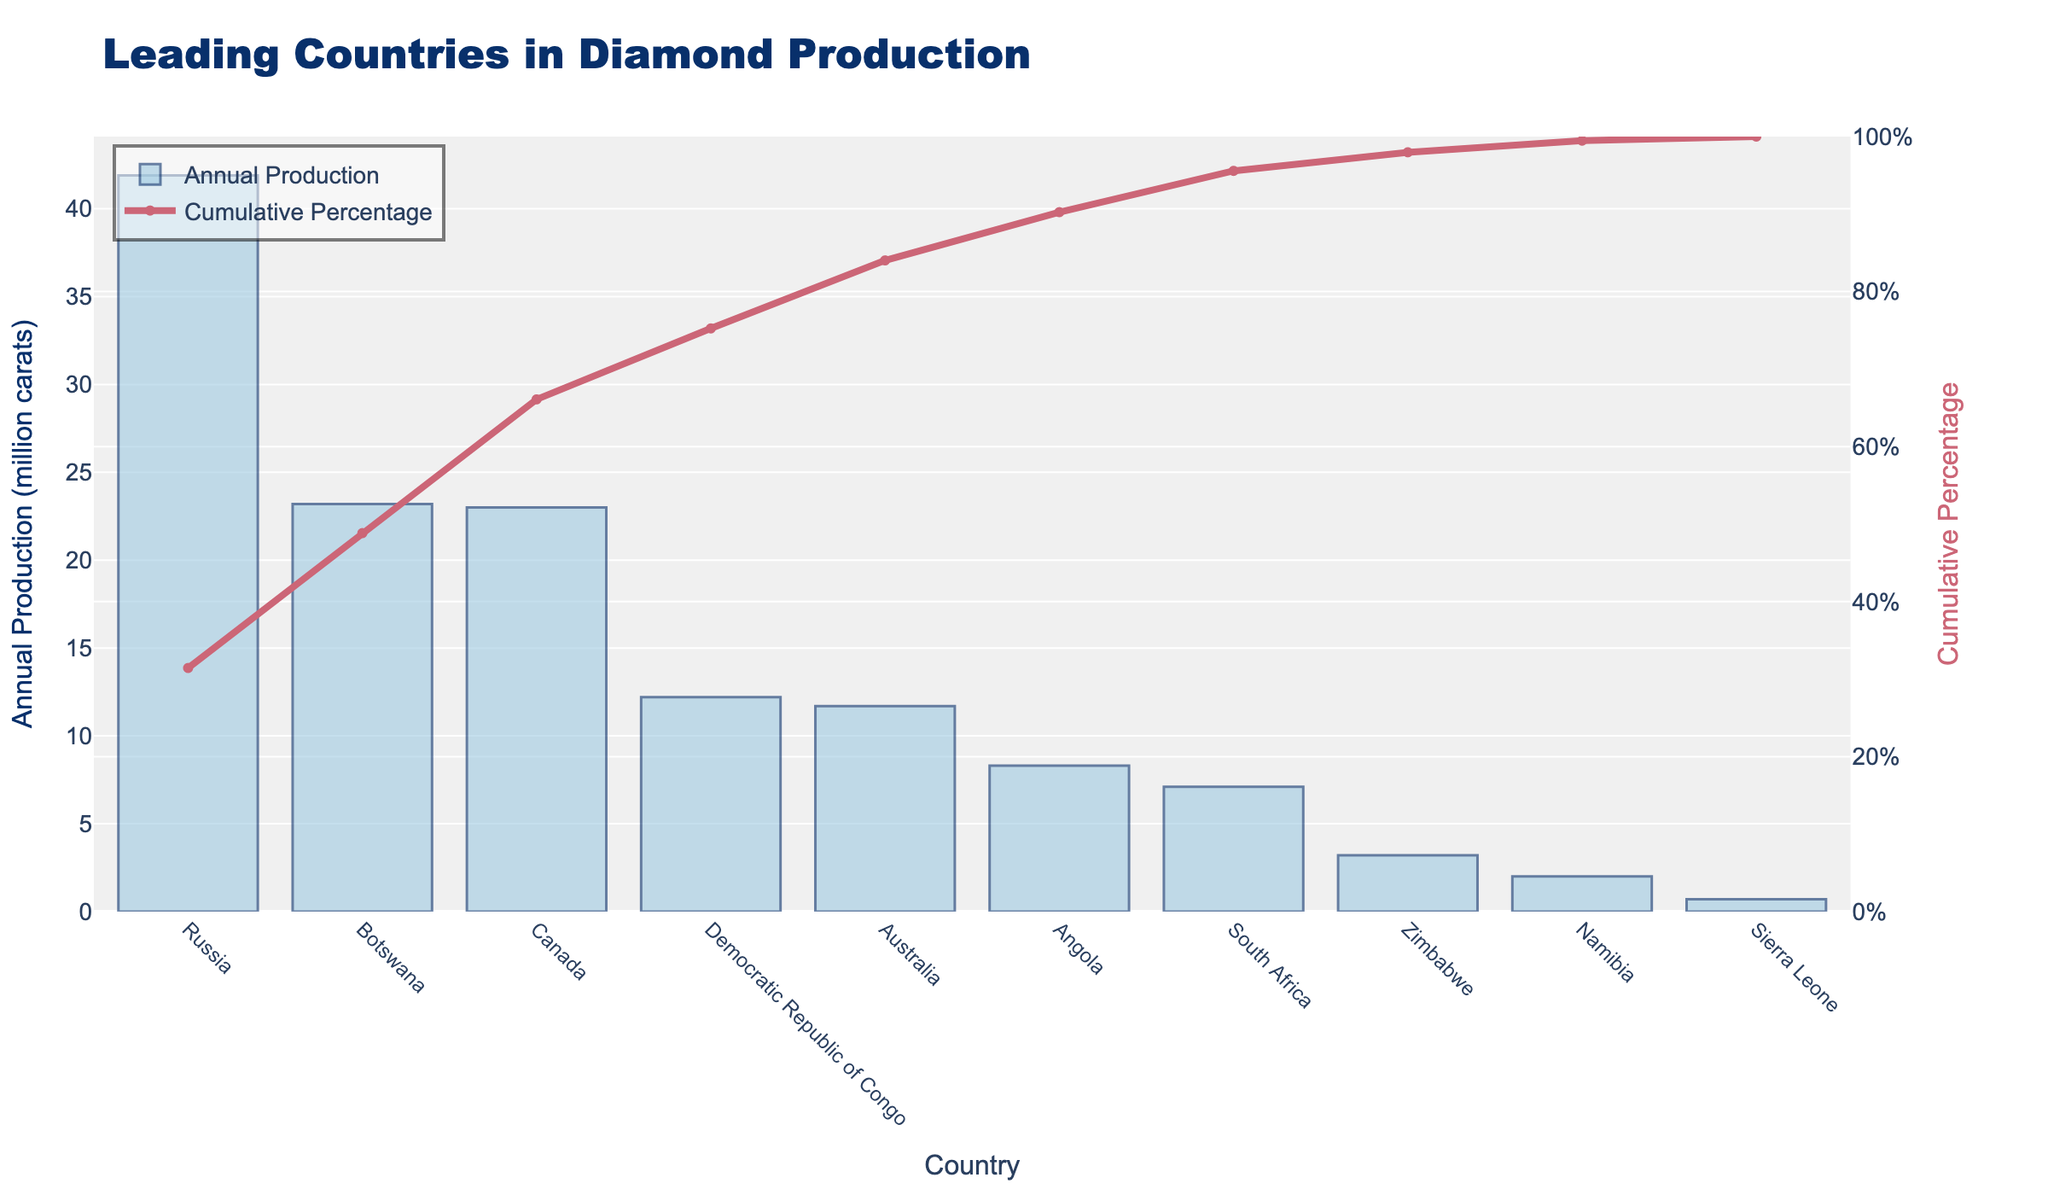What is the title of the figure? The title of the figure is displayed at the top, which is "Leading Countries in Diamond Production". This title helps identify the main subject of the figure.
Answer: Leading Countries in Diamond Production Which country has the highest annual diamond production? By observing the height of the bars, Russia has the highest bar indicating the highest annual diamond production among the countries listed.
Answer: Russia How many countries are represented in the chart? You can count the number of bars or labels on the x-axis. There are 10 countries represented in the chart.
Answer: 10 What color is used for the bars representing annual production? The color of the bars showing annual production is light blue (close to a shade of blue). This color distinction helps to identify the bars at a glance.
Answer: Light blue At what cumulative percentage is the fourth country? By looking at the cumulative percentage line, the fourth country from the left is the Democratic Republic of Congo, and its corresponding cumulative percentage on the secondary y-axis can be observed and is approximately 78%.
Answer: 78% What is the combined annual diamond production of Canada and Botswana? The annual production for Botswana is 23.2 million carats and for Canada is 23.0 million carats. Adding these gives 23.2 + 23.0 = 46.2 million carats.
Answer: 46.2 million carats Which country contributes more to annual diamond production, Angola or South Africa, and by how much? By comparing the height of the bars, Angola produces 8.3 million carats while South Africa produces 7.1 million carats. The difference is 8.3 - 7.1 = 1.2 million carats.
Answer: Angola by 1.2 million carats What percentage of total annual production is contributed by the top three countries combined? The top three countries are Russia, Botswana, and Canada. Their combined production is 41.9 + 23.2 + 23 = 88.1 million carats. The total production is 41.9+23.2+23+12.2+11.7+8.3+7.1+3.2+2+0.7 = 133.3 million carats. The percentage is (88.1/133.3) * 100 = 66.1%.
Answer: 66.1% What is the difference in cumulative percentage between the top producer and the country with the second-highest production? The cumulative percentage for Russia is around 31%, and for Botswana, it is around 48%. The difference is roughly 48% - 31% = 17%.
Answer: 17% Which country has the lowest annual diamond production, and what is its value? The smallest bar corresponds to Sierra Leone, with an annual production of 0.7 million carats.
Answer: Sierra Leone with 0.7 million carats 